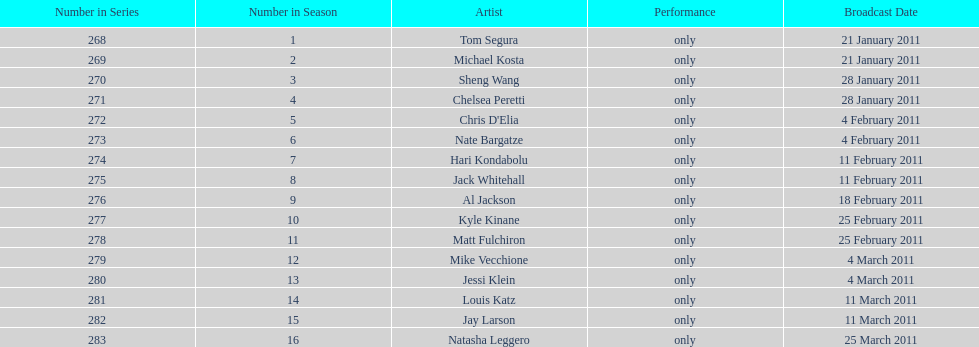Can you give me this table as a dict? {'header': ['Number in Series', 'Number in Season', 'Artist', 'Performance', 'Broadcast Date'], 'rows': [['268', '1', 'Tom Segura', 'only', '21 January 2011'], ['269', '2', 'Michael Kosta', 'only', '21 January 2011'], ['270', '3', 'Sheng Wang', 'only', '28 January 2011'], ['271', '4', 'Chelsea Peretti', 'only', '28 January 2011'], ['272', '5', "Chris D'Elia", 'only', '4 February 2011'], ['273', '6', 'Nate Bargatze', 'only', '4 February 2011'], ['274', '7', 'Hari Kondabolu', 'only', '11 February 2011'], ['275', '8', 'Jack Whitehall', 'only', '11 February 2011'], ['276', '9', 'Al Jackson', 'only', '18 February 2011'], ['277', '10', 'Kyle Kinane', 'only', '25 February 2011'], ['278', '11', 'Matt Fulchiron', 'only', '25 February 2011'], ['279', '12', 'Mike Vecchione', 'only', '4 March 2011'], ['280', '13', 'Jessi Klein', 'only', '4 March 2011'], ['281', '14', 'Louis Katz', 'only', '11 March 2011'], ['282', '15', 'Jay Larson', 'only', '11 March 2011'], ['283', '16', 'Natasha Leggero', 'only', '25 March 2011']]} Who appeared first tom segura or jay larson? Tom Segura. 